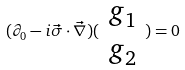<formula> <loc_0><loc_0><loc_500><loc_500>( \partial _ { 0 } - i \vec { \sigma } \cdot \vec { \nabla } ) ( \begin{array} { c } g _ { 1 } \\ g _ { 2 } \end{array} ) = 0</formula> 